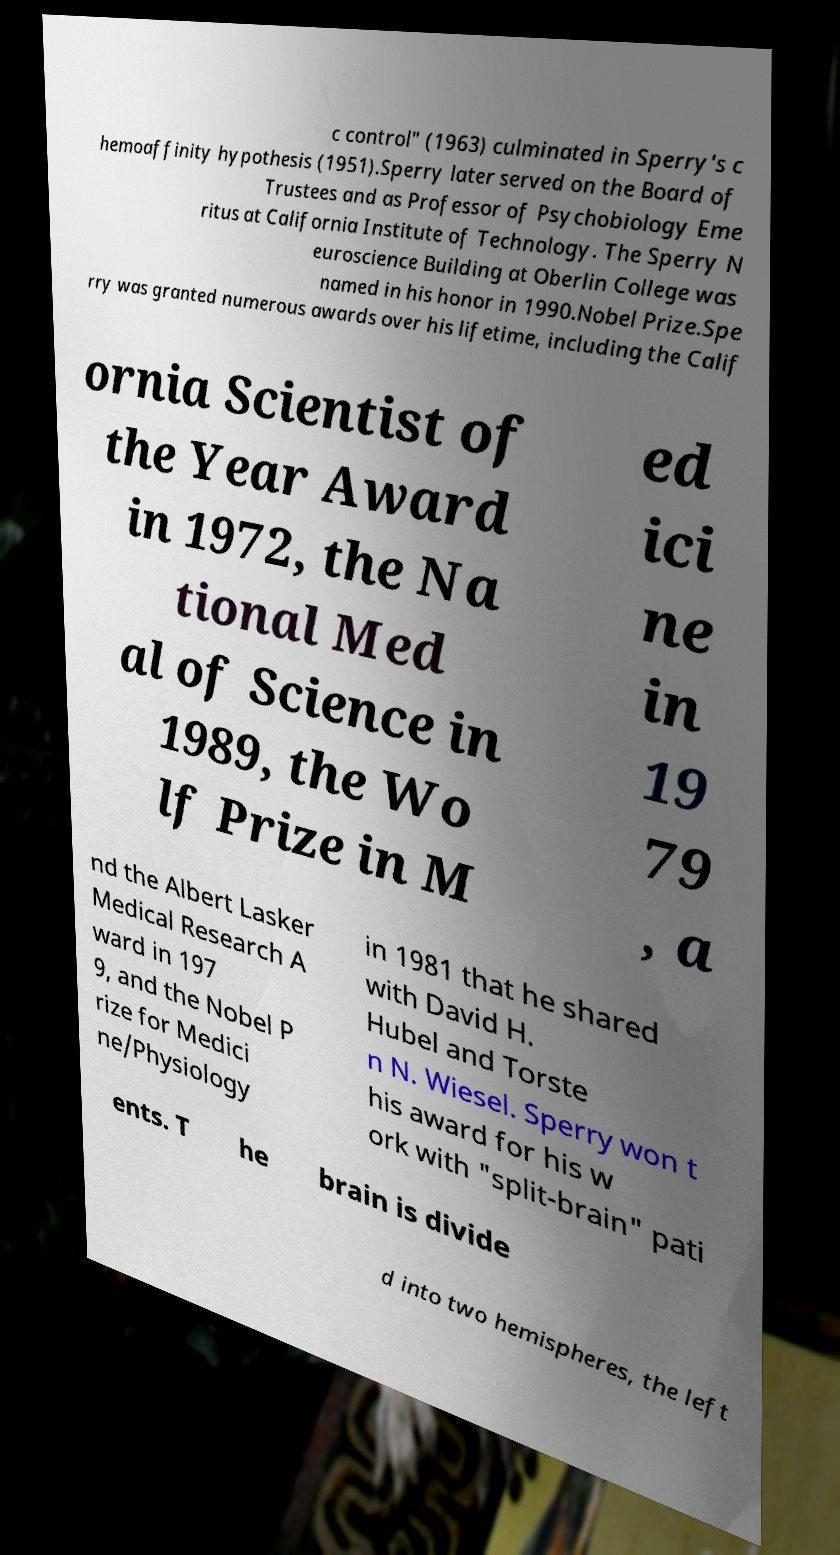I need the written content from this picture converted into text. Can you do that? c control" (1963) culminated in Sperry's c hemoaffinity hypothesis (1951).Sperry later served on the Board of Trustees and as Professor of Psychobiology Eme ritus at California Institute of Technology. The Sperry N euroscience Building at Oberlin College was named in his honor in 1990.Nobel Prize.Spe rry was granted numerous awards over his lifetime, including the Calif ornia Scientist of the Year Award in 1972, the Na tional Med al of Science in 1989, the Wo lf Prize in M ed ici ne in 19 79 , a nd the Albert Lasker Medical Research A ward in 197 9, and the Nobel P rize for Medici ne/Physiology in 1981 that he shared with David H. Hubel and Torste n N. Wiesel. Sperry won t his award for his w ork with "split-brain" pati ents. T he brain is divide d into two hemispheres, the left 